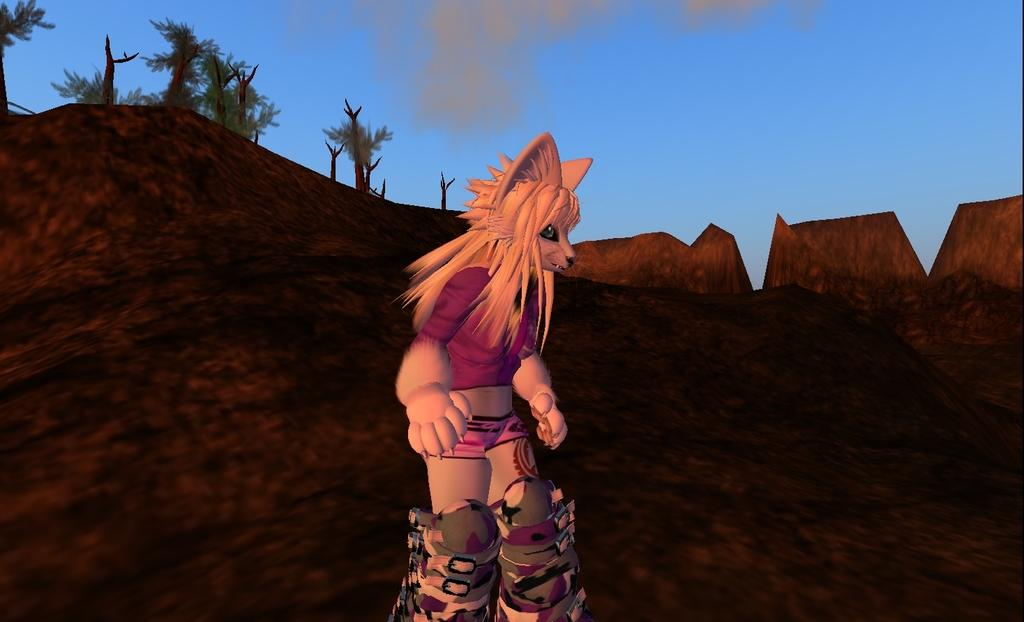What mythical creature is in the center of the image? There is a centaur in the center of the image. What type of landscape can be seen in the background of the image? There are mountains and trees in the background of the image. What part of the sky is visible in the image? The sky is visible in the background of the image, and there are clouds in it. What type of ear is visible on the centaur in the image? There is no ear visible on the centaur in the image, as centaurs are mythical creatures with human torsos and the ears of a horse. What sense is the centaur using to interact with the environment in the image? The image does not provide enough information to determine which sense the centaur is using to interact with the environment. 